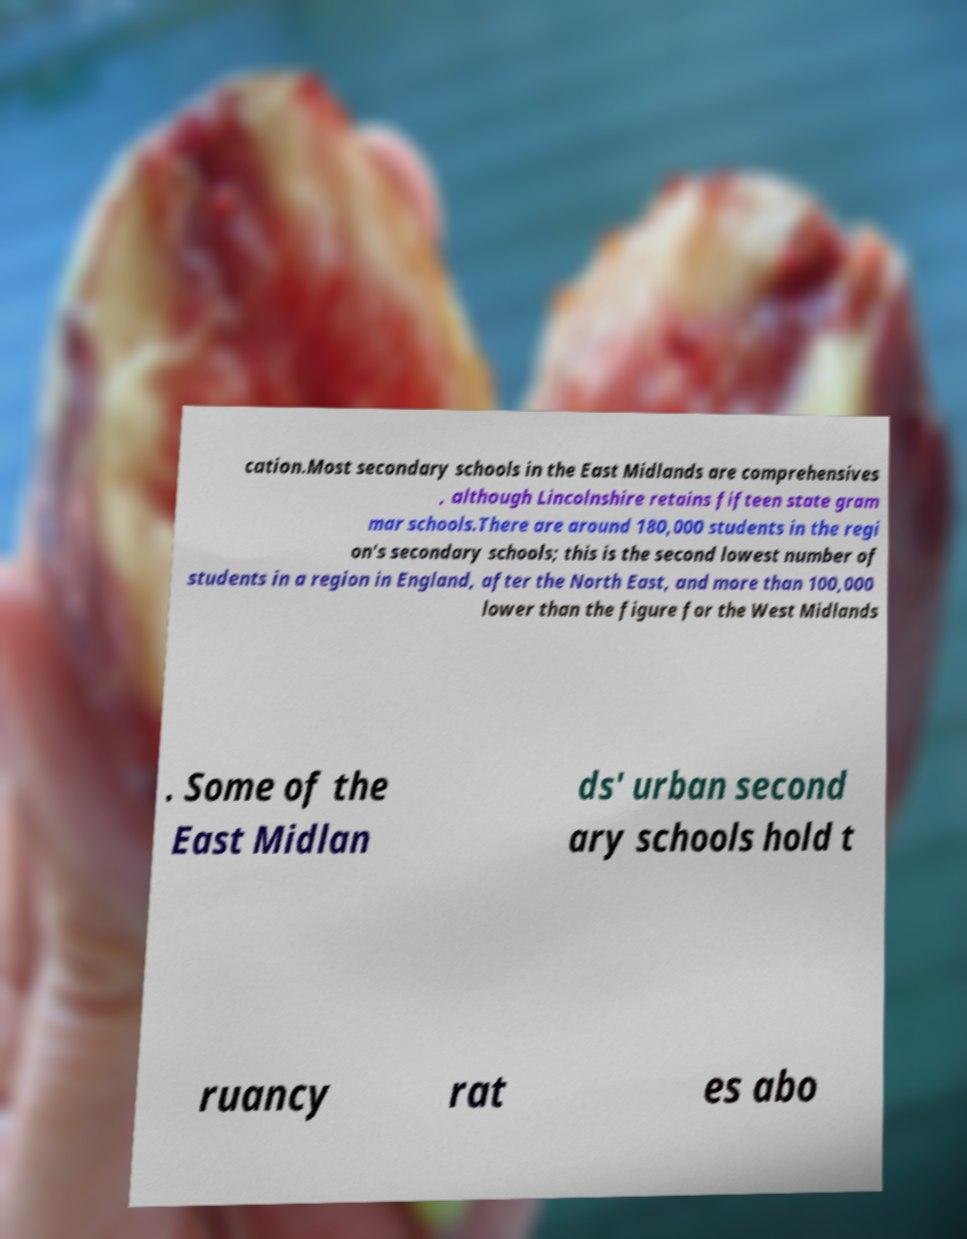Could you assist in decoding the text presented in this image and type it out clearly? cation.Most secondary schools in the East Midlands are comprehensives , although Lincolnshire retains fifteen state gram mar schools.There are around 180,000 students in the regi on's secondary schools; this is the second lowest number of students in a region in England, after the North East, and more than 100,000 lower than the figure for the West Midlands . Some of the East Midlan ds' urban second ary schools hold t ruancy rat es abo 